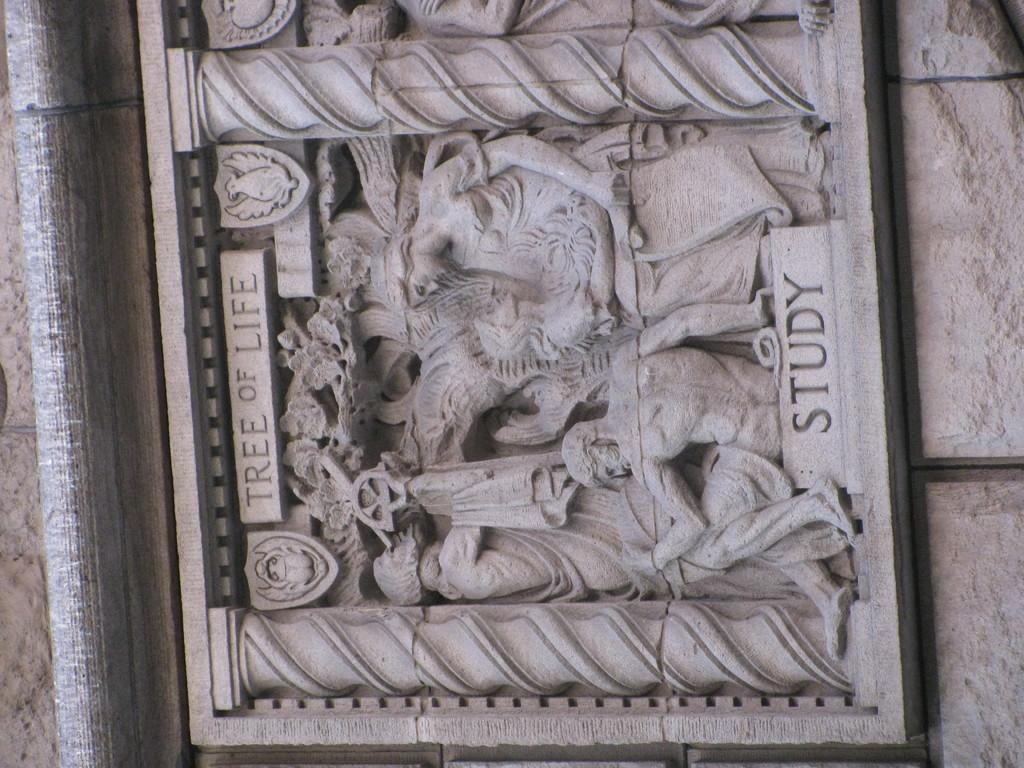What is located on the right side of the image? There is a wall on the right side of the image. What can be seen in the middle of the image? There is a carved stone in the middle of the image. How many dogs are playing the game of silver in the image? There are no dogs or any game of silver present in the image. The image only features a wall and a carved stone. 